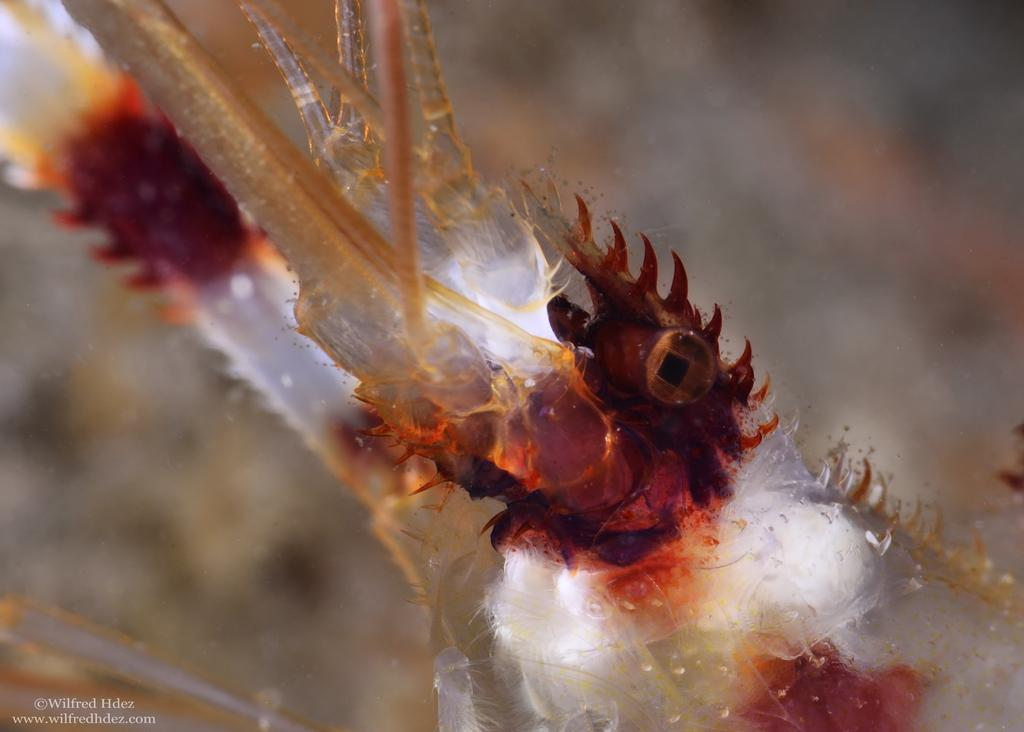What colors can be seen in the foreground of the image? In the foreground, there are species of white, brown, and light yellow colors. What can be observed in the background of the image? The background is not clear and contains text. Can we determine the time of day when the image was taken? Yes, the image was likely taken during the day, as there is no indication of darkness or artificial lighting. What type of net is being used to catch the birthday structure in the image? There is no net or birthday structure present in the image. 